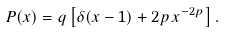<formula> <loc_0><loc_0><loc_500><loc_500>P ( x ) = q \left [ \delta ( x - 1 ) + 2 p \, x ^ { - 2 p } \right ] .</formula> 